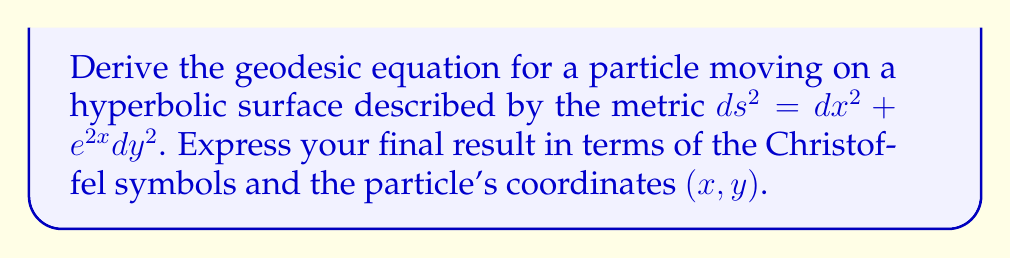Can you solve this math problem? To derive the geodesic equation for a particle moving on a hyperbolic surface, we'll follow these steps:

1) First, we identify the metric components:
   $g_{11} = 1$, $g_{22} = e^{2x}$, $g_{12} = g_{21} = 0$

2) Calculate the inverse metric:
   $g^{11} = 1$, $g^{22} = e^{-2x}$, $g^{12} = g^{21} = 0$

3) Compute the non-zero Christoffel symbols:
   $$\Gamma^i_{jk} = \frac{1}{2}g^{im}(\partial_j g_{mk} + \partial_k g_{jm} - \partial_m g_{jk})$$

   $\Gamma^1_{22} = -e^{2x}$
   $\Gamma^2_{12} = \Gamma^2_{21} = 1$

4) The geodesic equation in general form is:
   $$\frac{d^2x^\mu}{ds^2} + \Gamma^\mu_{\alpha\beta}\frac{dx^\alpha}{ds}\frac{dx^\beta}{ds} = 0$$

5) Expanding this for our 2D hyperbolic surface:

   For $\mu = 1$ (x-component):
   $$\frac{d^2x}{ds^2} + \Gamma^1_{22}\left(\frac{dy}{ds}\right)^2 = 0$$

   For $\mu = 2$ (y-component):
   $$\frac{d^2y}{ds^2} + 2\Gamma^2_{12}\frac{dx}{ds}\frac{dy}{ds} = 0$$

6) Substituting the Christoffel symbols:

   $$\frac{d^2x}{ds^2} - e^{2x}\left(\frac{dy}{ds}\right)^2 = 0$$

   $$\frac{d^2y}{ds^2} + 2\frac{dx}{ds}\frac{dy}{ds} = 0$$

These equations describe the geodesic motion on the hyperbolic surface.
Answer: $$\frac{d^2x^\mu}{ds^2} + \Gamma^\mu_{\alpha\beta}\frac{dx^\alpha}{ds}\frac{dx^\beta}{ds} = 0$$
where $\Gamma^1_{22} = -e^{2x}$, $\Gamma^2_{12} = \Gamma^2_{21} = 1$, and all other $\Gamma^\mu_{\alpha\beta} = 0$ 